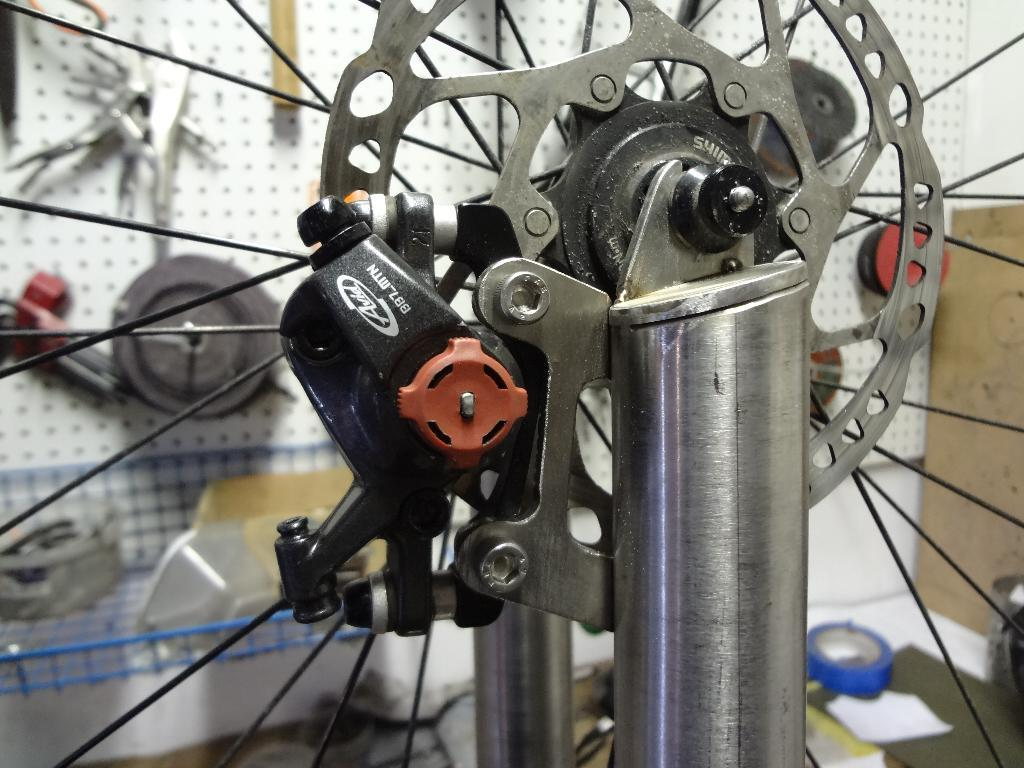What type of mechanical instrument is visible in the image? There is a mechanical instrument in the image that resembles a hub gear. What else can be seen in the background of the image? There are other objects in the background of the image. What is the background setting in the image? There is a wall in the background of the image. What type of throat-soothing jam is being prepared in the image? There is no jam or any indication of food preparation in the image; it features a mechanical instrument and a wall in the background. 